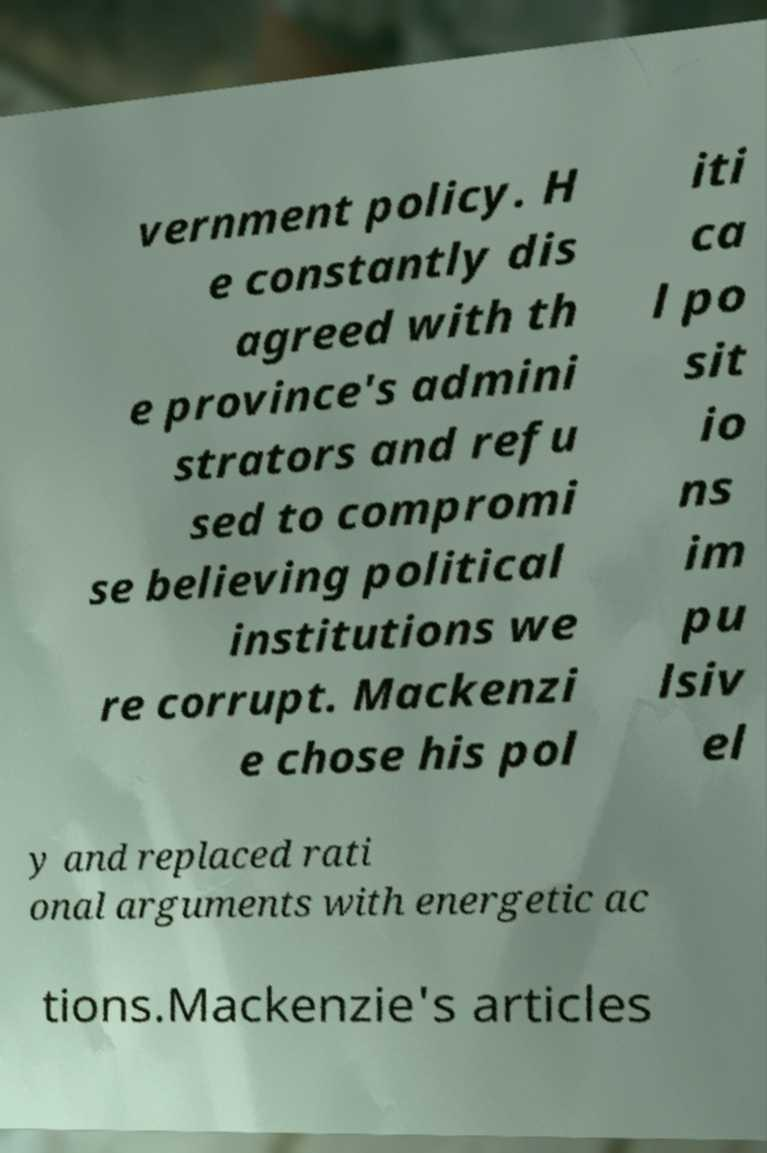What messages or text are displayed in this image? I need them in a readable, typed format. vernment policy. H e constantly dis agreed with th e province's admini strators and refu sed to compromi se believing political institutions we re corrupt. Mackenzi e chose his pol iti ca l po sit io ns im pu lsiv el y and replaced rati onal arguments with energetic ac tions.Mackenzie's articles 